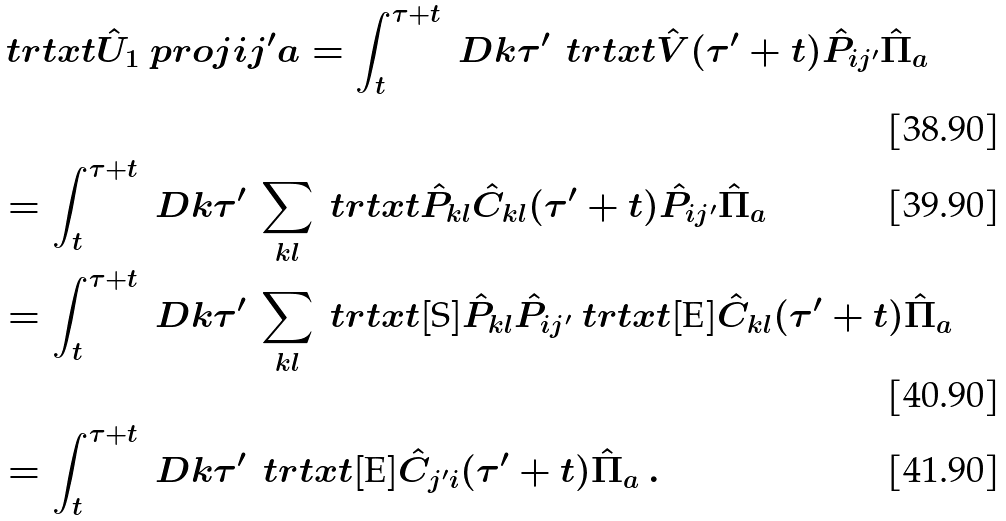Convert formula to latex. <formula><loc_0><loc_0><loc_500><loc_500>& \ t r t x t { \hat { U } _ { 1 } \ p r o j { i j ^ { \prime } } { a } } = \int _ { t } ^ { \tau + t } \ D k \tau ^ { \prime } \, \ t r t x t { \hat { V } ( \tau ^ { \prime } + t ) \hat { P } _ { i j ^ { \prime } } \hat { \Pi } _ { a } } \\ & = \int _ { t } ^ { \tau + t } \ D k \tau ^ { \prime } \, \sum _ { k l } \ t r t x t { \hat { P } _ { k l } \hat { C } _ { k l } ( \tau ^ { \prime } + t ) \hat { P } _ { i j ^ { \prime } } \hat { \Pi } _ { a } } \\ & = \int _ { t } ^ { \tau + t } \ D k \tau ^ { \prime } \, \sum _ { k l } \ t r t x t [ \text {S} ] { \hat { P } _ { k l } \hat { P } _ { i j ^ { \prime } } } \ t r t x t [ \text {E} ] { \hat { C } _ { k l } ( \tau ^ { \prime } + t ) \hat { \Pi } _ { a } } \\ & = \int _ { t } ^ { \tau + t } \ D k \tau ^ { \prime } \, \ t r t x t [ \text {E} ] { \hat { C } _ { j ^ { \prime } i } ( \tau ^ { \prime } + t ) \hat { \Pi } _ { a } } \, .</formula> 